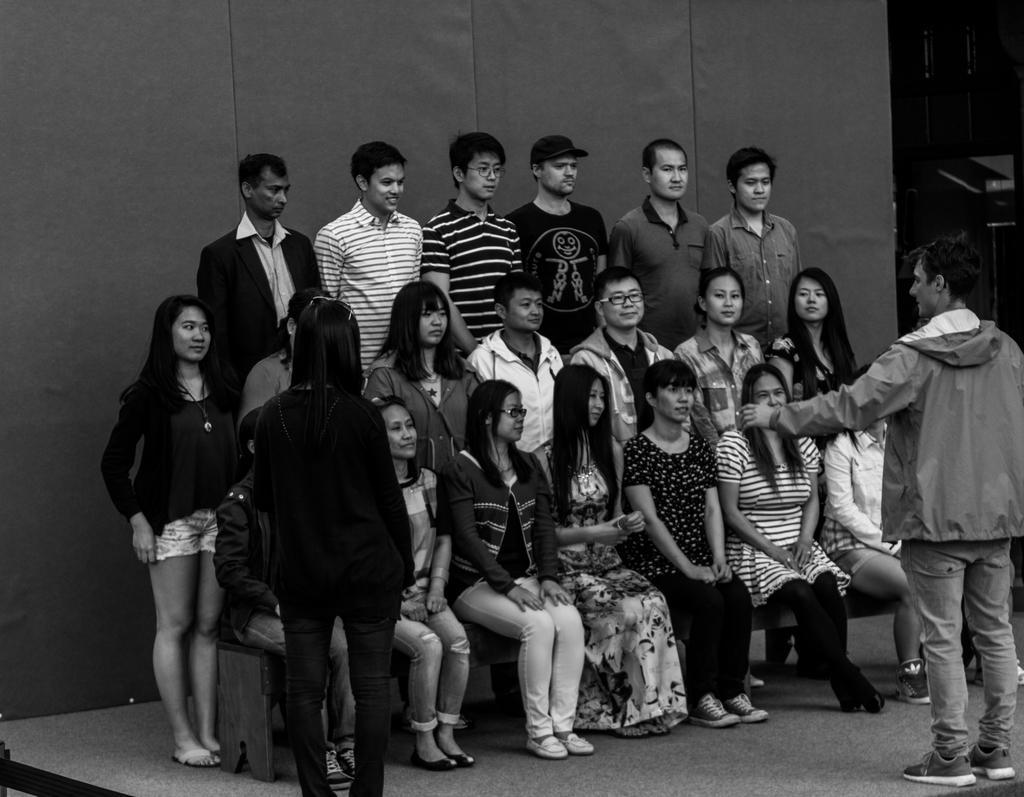Please provide a concise description of this image. This is a black and white image and here we can see people and some are sitting. At the bottom, there is a floor. 